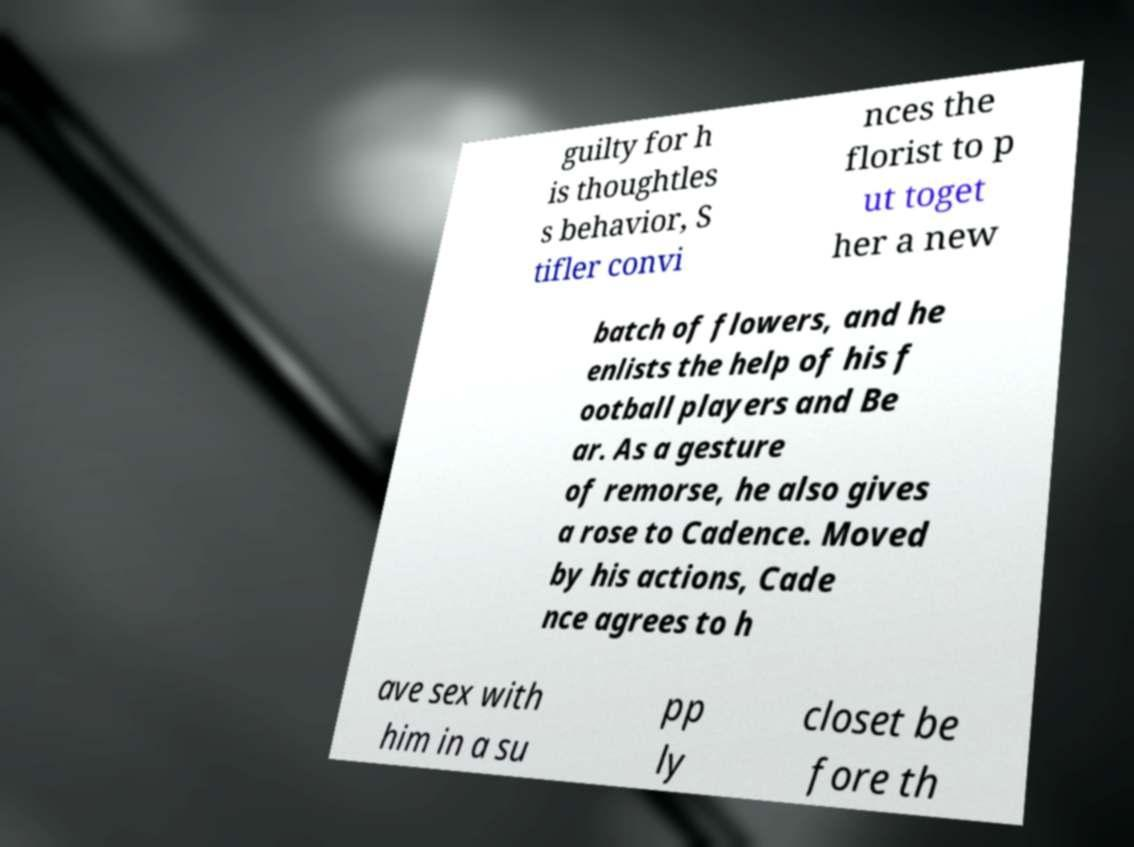Could you extract and type out the text from this image? guilty for h is thoughtles s behavior, S tifler convi nces the florist to p ut toget her a new batch of flowers, and he enlists the help of his f ootball players and Be ar. As a gesture of remorse, he also gives a rose to Cadence. Moved by his actions, Cade nce agrees to h ave sex with him in a su pp ly closet be fore th 